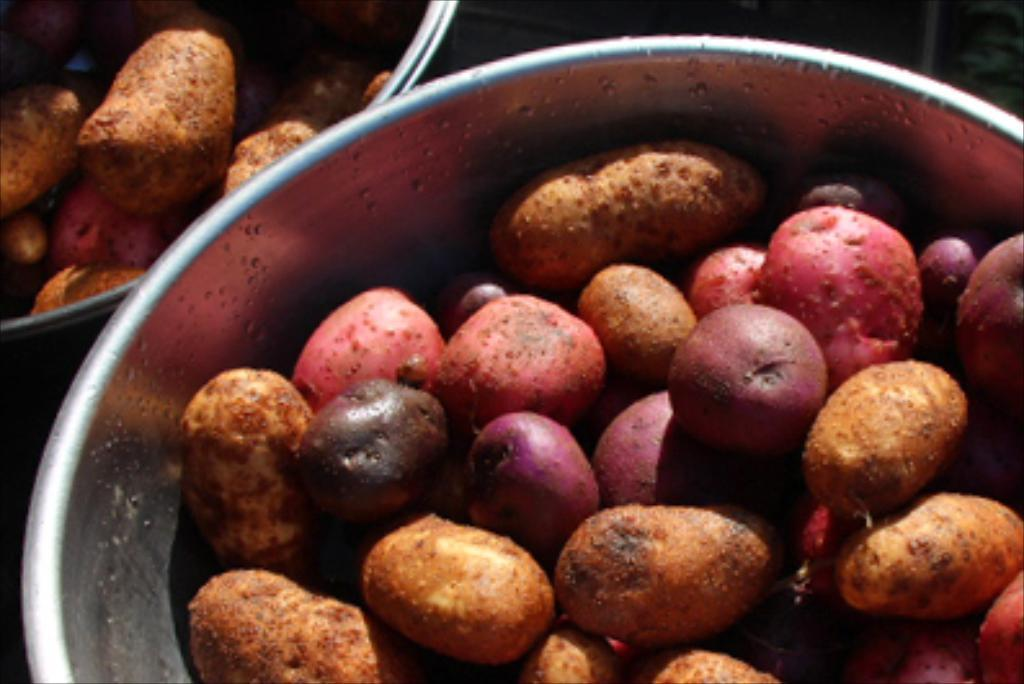How many containers are visible in the image? There are two containers in the image. What are the containers holding? The containers contain a group of vegetables. How many teeth can be seen in the image? There are no teeth visible in the image; it features two containers with vegetables. 